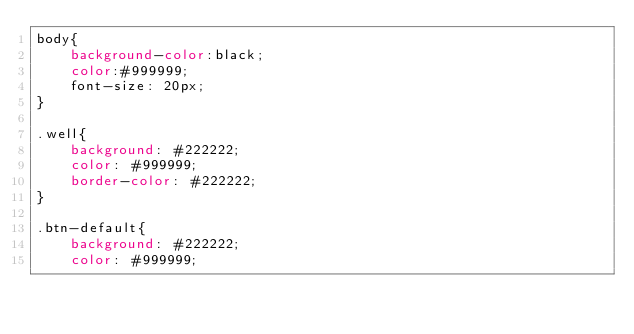Convert code to text. <code><loc_0><loc_0><loc_500><loc_500><_CSS_>body{
    background-color:black;
    color:#999999;
    font-size: 20px;
}

.well{
    background: #222222;
    color: #999999;
    border-color: #222222;
}

.btn-default{
    background: #222222;
    color: #999999;</code> 